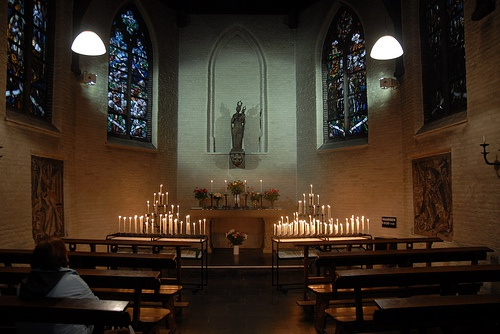Describe the objects in this image and their specific colors. I can see bench in black, maroon, and brown tones, bench in black, maroon, and gray tones, bench in black, gray, and darkgray tones, bench in black, maroon, and brown tones, and people in black, gray, and purple tones in this image. 